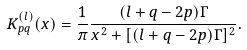Convert formula to latex. <formula><loc_0><loc_0><loc_500><loc_500>K _ { p q } ^ { ( l ) } ( x ) = \frac { 1 } { \pi } \frac { ( l + q - 2 p ) \Gamma } { x ^ { 2 } + [ ( l + q - 2 p ) \Gamma ] ^ { 2 } } .</formula> 